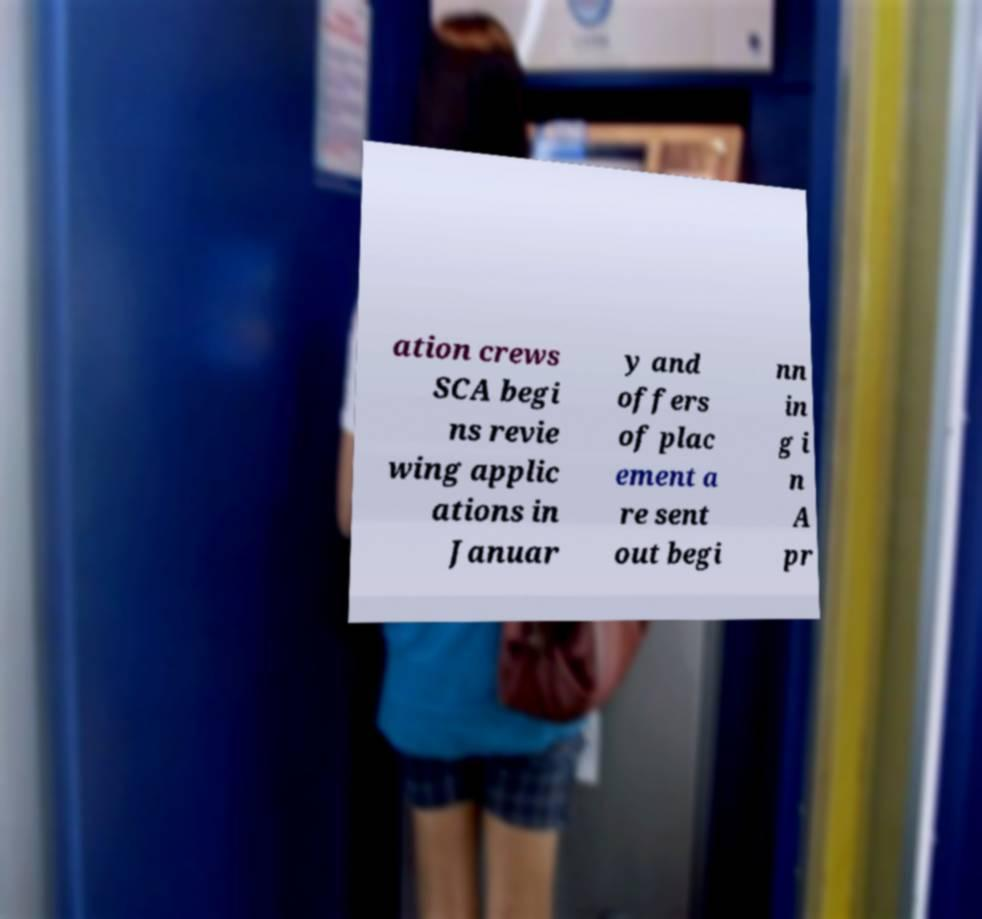Please read and relay the text visible in this image. What does it say? ation crews SCA begi ns revie wing applic ations in Januar y and offers of plac ement a re sent out begi nn in g i n A pr 